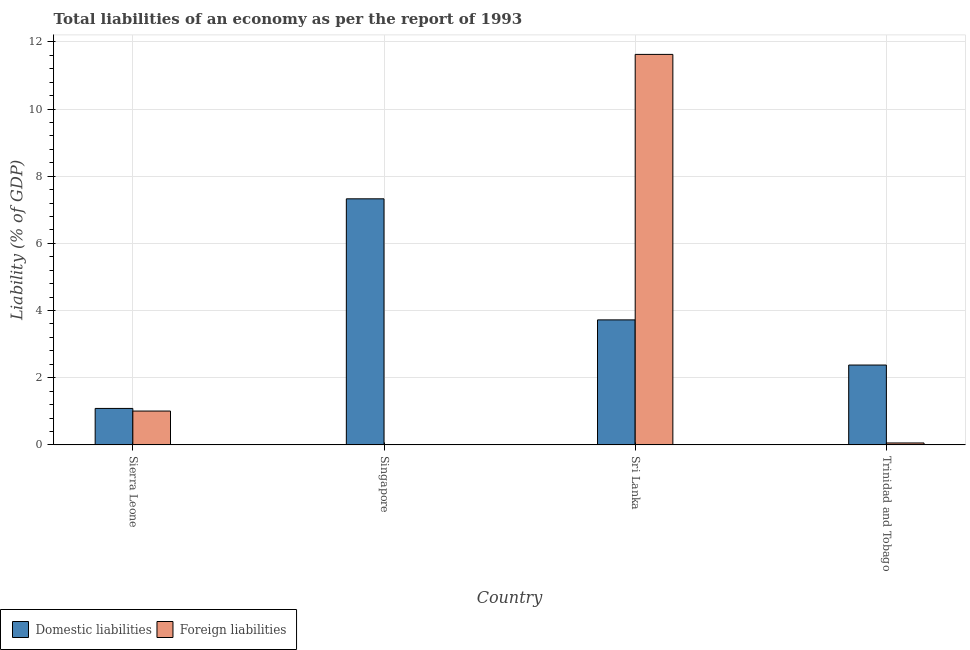How many bars are there on the 1st tick from the right?
Provide a short and direct response. 2. What is the label of the 4th group of bars from the left?
Give a very brief answer. Trinidad and Tobago. In how many cases, is the number of bars for a given country not equal to the number of legend labels?
Your answer should be very brief. 1. What is the incurrence of foreign liabilities in Trinidad and Tobago?
Your answer should be very brief. 0.06. Across all countries, what is the maximum incurrence of foreign liabilities?
Offer a very short reply. 11.63. In which country was the incurrence of foreign liabilities maximum?
Provide a succinct answer. Sri Lanka. What is the total incurrence of domestic liabilities in the graph?
Make the answer very short. 14.51. What is the difference between the incurrence of domestic liabilities in Sierra Leone and that in Trinidad and Tobago?
Your answer should be compact. -1.29. What is the difference between the incurrence of foreign liabilities in Singapore and the incurrence of domestic liabilities in Trinidad and Tobago?
Give a very brief answer. -2.38. What is the average incurrence of domestic liabilities per country?
Offer a very short reply. 3.63. What is the difference between the incurrence of foreign liabilities and incurrence of domestic liabilities in Sierra Leone?
Your response must be concise. -0.08. What is the ratio of the incurrence of domestic liabilities in Sierra Leone to that in Sri Lanka?
Your response must be concise. 0.29. What is the difference between the highest and the second highest incurrence of domestic liabilities?
Provide a short and direct response. 3.6. What is the difference between the highest and the lowest incurrence of domestic liabilities?
Make the answer very short. 6.24. Is the sum of the incurrence of foreign liabilities in Sierra Leone and Trinidad and Tobago greater than the maximum incurrence of domestic liabilities across all countries?
Offer a very short reply. No. How many bars are there?
Offer a very short reply. 7. Are all the bars in the graph horizontal?
Give a very brief answer. No. How many countries are there in the graph?
Provide a succinct answer. 4. What is the difference between two consecutive major ticks on the Y-axis?
Offer a very short reply. 2. Are the values on the major ticks of Y-axis written in scientific E-notation?
Make the answer very short. No. Does the graph contain any zero values?
Make the answer very short. Yes. How many legend labels are there?
Give a very brief answer. 2. What is the title of the graph?
Your response must be concise. Total liabilities of an economy as per the report of 1993. What is the label or title of the Y-axis?
Keep it short and to the point. Liability (% of GDP). What is the Liability (% of GDP) in Domestic liabilities in Sierra Leone?
Offer a very short reply. 1.09. What is the Liability (% of GDP) in Foreign liabilities in Sierra Leone?
Your answer should be compact. 1.01. What is the Liability (% of GDP) of Domestic liabilities in Singapore?
Provide a succinct answer. 7.33. What is the Liability (% of GDP) in Domestic liabilities in Sri Lanka?
Provide a succinct answer. 3.72. What is the Liability (% of GDP) in Foreign liabilities in Sri Lanka?
Your answer should be very brief. 11.63. What is the Liability (% of GDP) of Domestic liabilities in Trinidad and Tobago?
Give a very brief answer. 2.38. What is the Liability (% of GDP) in Foreign liabilities in Trinidad and Tobago?
Provide a short and direct response. 0.06. Across all countries, what is the maximum Liability (% of GDP) in Domestic liabilities?
Give a very brief answer. 7.33. Across all countries, what is the maximum Liability (% of GDP) in Foreign liabilities?
Give a very brief answer. 11.63. Across all countries, what is the minimum Liability (% of GDP) of Domestic liabilities?
Provide a succinct answer. 1.09. What is the total Liability (% of GDP) of Domestic liabilities in the graph?
Provide a short and direct response. 14.51. What is the total Liability (% of GDP) of Foreign liabilities in the graph?
Ensure brevity in your answer.  12.69. What is the difference between the Liability (% of GDP) of Domestic liabilities in Sierra Leone and that in Singapore?
Your answer should be compact. -6.24. What is the difference between the Liability (% of GDP) in Domestic liabilities in Sierra Leone and that in Sri Lanka?
Ensure brevity in your answer.  -2.64. What is the difference between the Liability (% of GDP) of Foreign liabilities in Sierra Leone and that in Sri Lanka?
Offer a terse response. -10.62. What is the difference between the Liability (% of GDP) in Domestic liabilities in Sierra Leone and that in Trinidad and Tobago?
Give a very brief answer. -1.29. What is the difference between the Liability (% of GDP) in Foreign liabilities in Sierra Leone and that in Trinidad and Tobago?
Offer a very short reply. 0.95. What is the difference between the Liability (% of GDP) in Domestic liabilities in Singapore and that in Sri Lanka?
Your response must be concise. 3.6. What is the difference between the Liability (% of GDP) in Domestic liabilities in Singapore and that in Trinidad and Tobago?
Keep it short and to the point. 4.95. What is the difference between the Liability (% of GDP) in Domestic liabilities in Sri Lanka and that in Trinidad and Tobago?
Ensure brevity in your answer.  1.34. What is the difference between the Liability (% of GDP) in Foreign liabilities in Sri Lanka and that in Trinidad and Tobago?
Provide a succinct answer. 11.57. What is the difference between the Liability (% of GDP) in Domestic liabilities in Sierra Leone and the Liability (% of GDP) in Foreign liabilities in Sri Lanka?
Your answer should be compact. -10.54. What is the difference between the Liability (% of GDP) of Domestic liabilities in Sierra Leone and the Liability (% of GDP) of Foreign liabilities in Trinidad and Tobago?
Provide a succinct answer. 1.03. What is the difference between the Liability (% of GDP) of Domestic liabilities in Singapore and the Liability (% of GDP) of Foreign liabilities in Sri Lanka?
Your answer should be compact. -4.3. What is the difference between the Liability (% of GDP) of Domestic liabilities in Singapore and the Liability (% of GDP) of Foreign liabilities in Trinidad and Tobago?
Provide a succinct answer. 7.27. What is the difference between the Liability (% of GDP) in Domestic liabilities in Sri Lanka and the Liability (% of GDP) in Foreign liabilities in Trinidad and Tobago?
Ensure brevity in your answer.  3.66. What is the average Liability (% of GDP) in Domestic liabilities per country?
Your response must be concise. 3.63. What is the average Liability (% of GDP) of Foreign liabilities per country?
Provide a succinct answer. 3.17. What is the difference between the Liability (% of GDP) in Domestic liabilities and Liability (% of GDP) in Foreign liabilities in Sierra Leone?
Your answer should be compact. 0.08. What is the difference between the Liability (% of GDP) in Domestic liabilities and Liability (% of GDP) in Foreign liabilities in Sri Lanka?
Provide a succinct answer. -7.9. What is the difference between the Liability (% of GDP) of Domestic liabilities and Liability (% of GDP) of Foreign liabilities in Trinidad and Tobago?
Provide a short and direct response. 2.32. What is the ratio of the Liability (% of GDP) of Domestic liabilities in Sierra Leone to that in Singapore?
Provide a short and direct response. 0.15. What is the ratio of the Liability (% of GDP) in Domestic liabilities in Sierra Leone to that in Sri Lanka?
Your answer should be compact. 0.29. What is the ratio of the Liability (% of GDP) in Foreign liabilities in Sierra Leone to that in Sri Lanka?
Make the answer very short. 0.09. What is the ratio of the Liability (% of GDP) of Domestic liabilities in Sierra Leone to that in Trinidad and Tobago?
Ensure brevity in your answer.  0.46. What is the ratio of the Liability (% of GDP) of Foreign liabilities in Sierra Leone to that in Trinidad and Tobago?
Offer a terse response. 17.53. What is the ratio of the Liability (% of GDP) of Domestic liabilities in Singapore to that in Sri Lanka?
Make the answer very short. 1.97. What is the ratio of the Liability (% of GDP) in Domestic liabilities in Singapore to that in Trinidad and Tobago?
Make the answer very short. 3.08. What is the ratio of the Liability (% of GDP) in Domestic liabilities in Sri Lanka to that in Trinidad and Tobago?
Your answer should be very brief. 1.57. What is the ratio of the Liability (% of GDP) of Foreign liabilities in Sri Lanka to that in Trinidad and Tobago?
Give a very brief answer. 202.22. What is the difference between the highest and the second highest Liability (% of GDP) of Domestic liabilities?
Give a very brief answer. 3.6. What is the difference between the highest and the second highest Liability (% of GDP) of Foreign liabilities?
Your response must be concise. 10.62. What is the difference between the highest and the lowest Liability (% of GDP) of Domestic liabilities?
Make the answer very short. 6.24. What is the difference between the highest and the lowest Liability (% of GDP) in Foreign liabilities?
Your response must be concise. 11.63. 